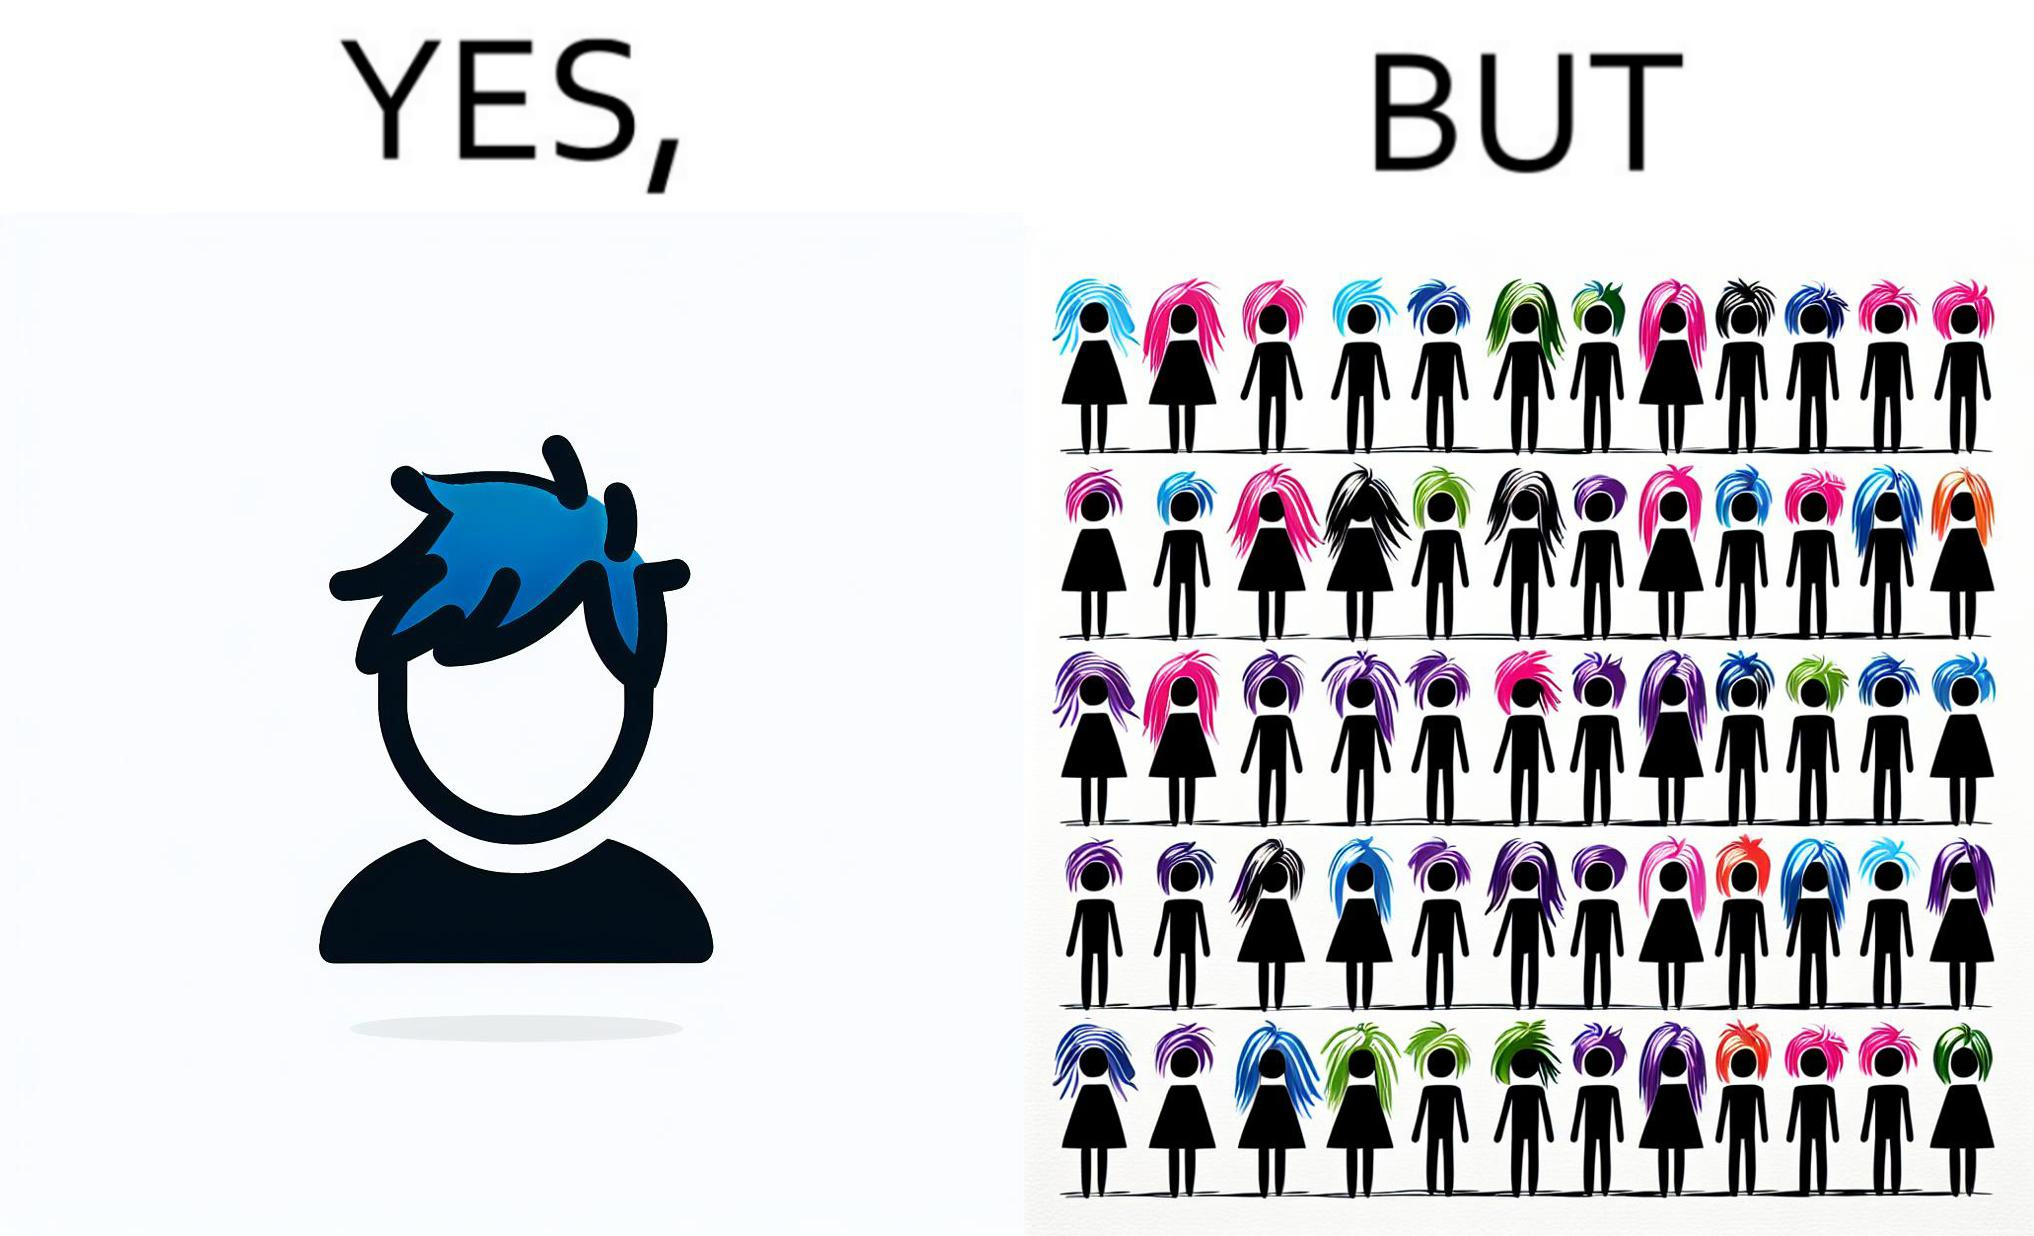Why is this image considered satirical? The image is funny, as one person with a hair dyed blue seems to symbolize that the person is going against the grain, however, when we zoom out, the group of people have hair dyed in several, different colors, showing that, dyeing hair is the new normal. 